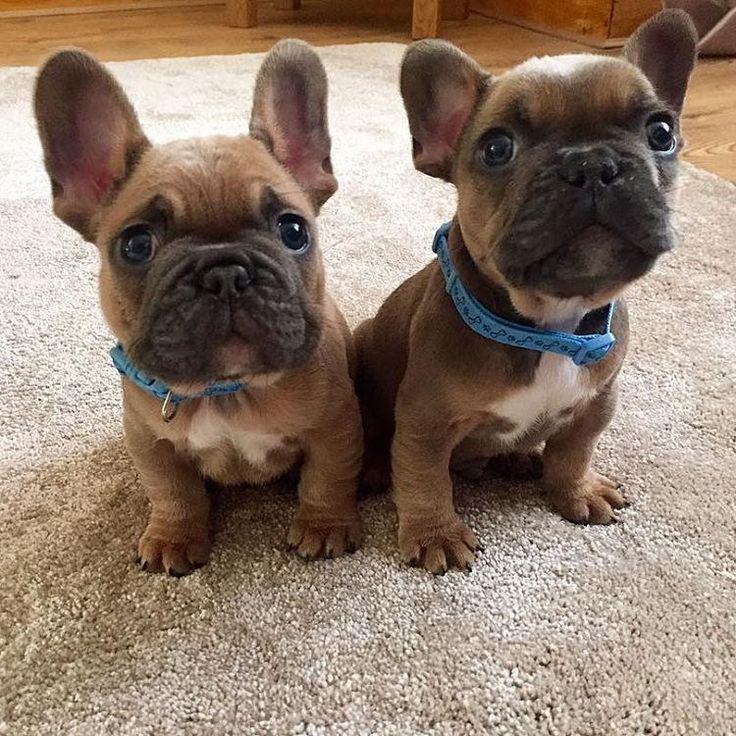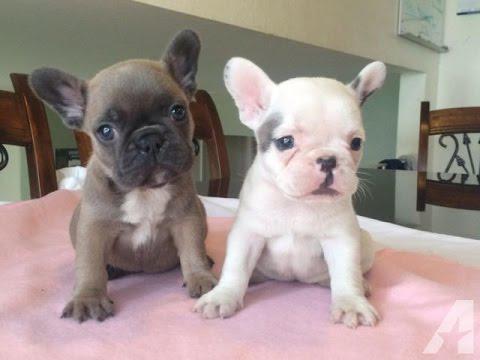The first image is the image on the left, the second image is the image on the right. Analyze the images presented: Is the assertion "Each image contains a single pug puppy, and each dog's gaze is in the same general direction." valid? Answer yes or no. No. 